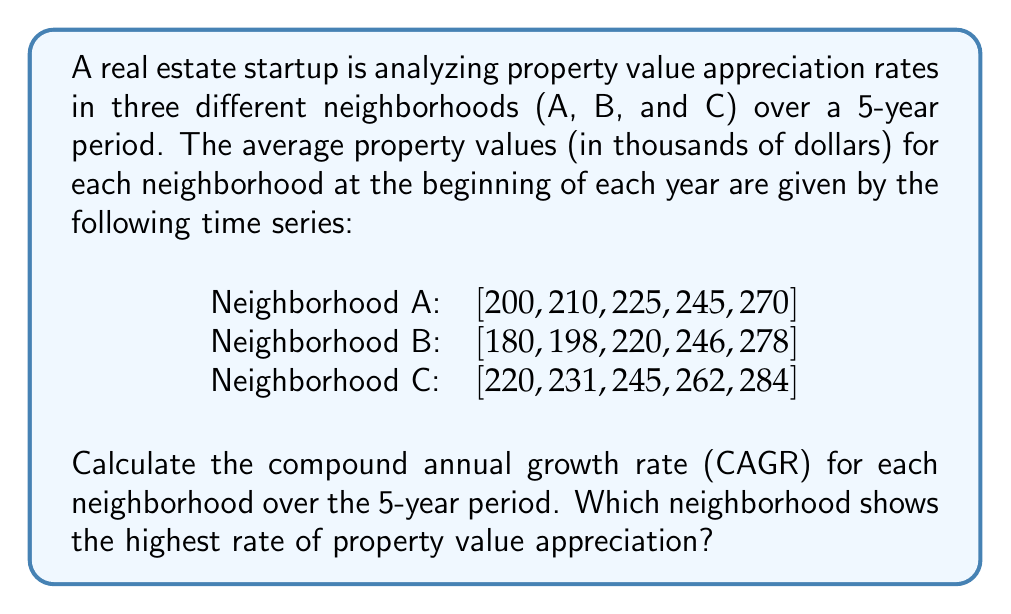Can you answer this question? To solve this problem, we need to calculate the Compound Annual Growth Rate (CAGR) for each neighborhood. The CAGR is given by the formula:

$$ CAGR = \left(\frac{Ending Value}{Beginning Value}\right)^{\frac{1}{n}} - 1 $$

Where $n$ is the number of years.

Let's calculate the CAGR for each neighborhood:

1. Neighborhood A:
   $$ CAGR_A = \left(\frac{270}{200}\right)^{\frac{1}{5}} - 1 = 1.0617 - 1 = 0.0617 = 6.17\% $$

2. Neighborhood B:
   $$ CAGR_B = \left(\frac{278}{180}\right)^{\frac{1}{5}} - 1 = 1.0909 - 1 = 0.0909 = 9.09\% $$

3. Neighborhood C:
   $$ CAGR_C = \left(\frac{284}{220}\right)^{\frac{1}{5}} - 1 = 1.0524 - 1 = 0.0524 = 5.24\% $$

Comparing the CAGR values:
$CAGR_B > CAGR_A > CAGR_C$
Answer: Neighborhood B shows the highest rate of property value appreciation with a CAGR of 9.09%. 